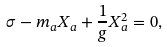<formula> <loc_0><loc_0><loc_500><loc_500>\sigma - m _ { a } X _ { a } + \frac { 1 } { g } X _ { a } ^ { 2 } = 0 ,</formula> 